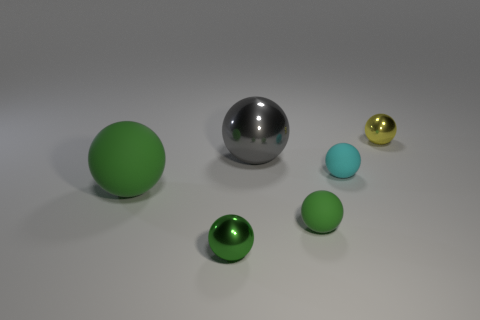Subtract all yellow cubes. How many green balls are left? 3 Subtract 3 balls. How many balls are left? 3 Subtract all tiny yellow balls. How many balls are left? 5 Subtract all green spheres. How many spheres are left? 3 Add 4 small green shiny things. How many objects exist? 10 Add 1 small green metal things. How many small green metal things are left? 2 Add 4 blue matte objects. How many blue matte objects exist? 4 Subtract 0 yellow cylinders. How many objects are left? 6 Subtract all cyan spheres. Subtract all purple cubes. How many spheres are left? 5 Subtract all big gray balls. Subtract all green shiny objects. How many objects are left? 4 